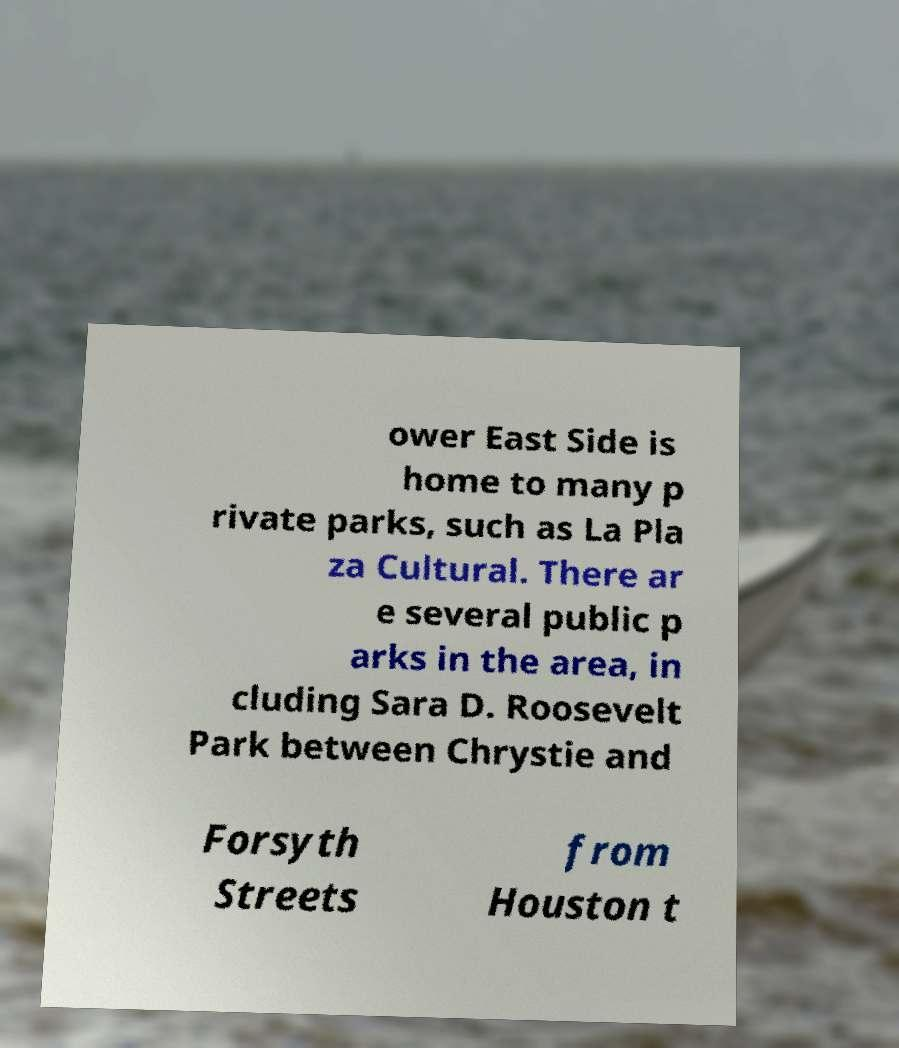Please identify and transcribe the text found in this image. ower East Side is home to many p rivate parks, such as La Pla za Cultural. There ar e several public p arks in the area, in cluding Sara D. Roosevelt Park between Chrystie and Forsyth Streets from Houston t 